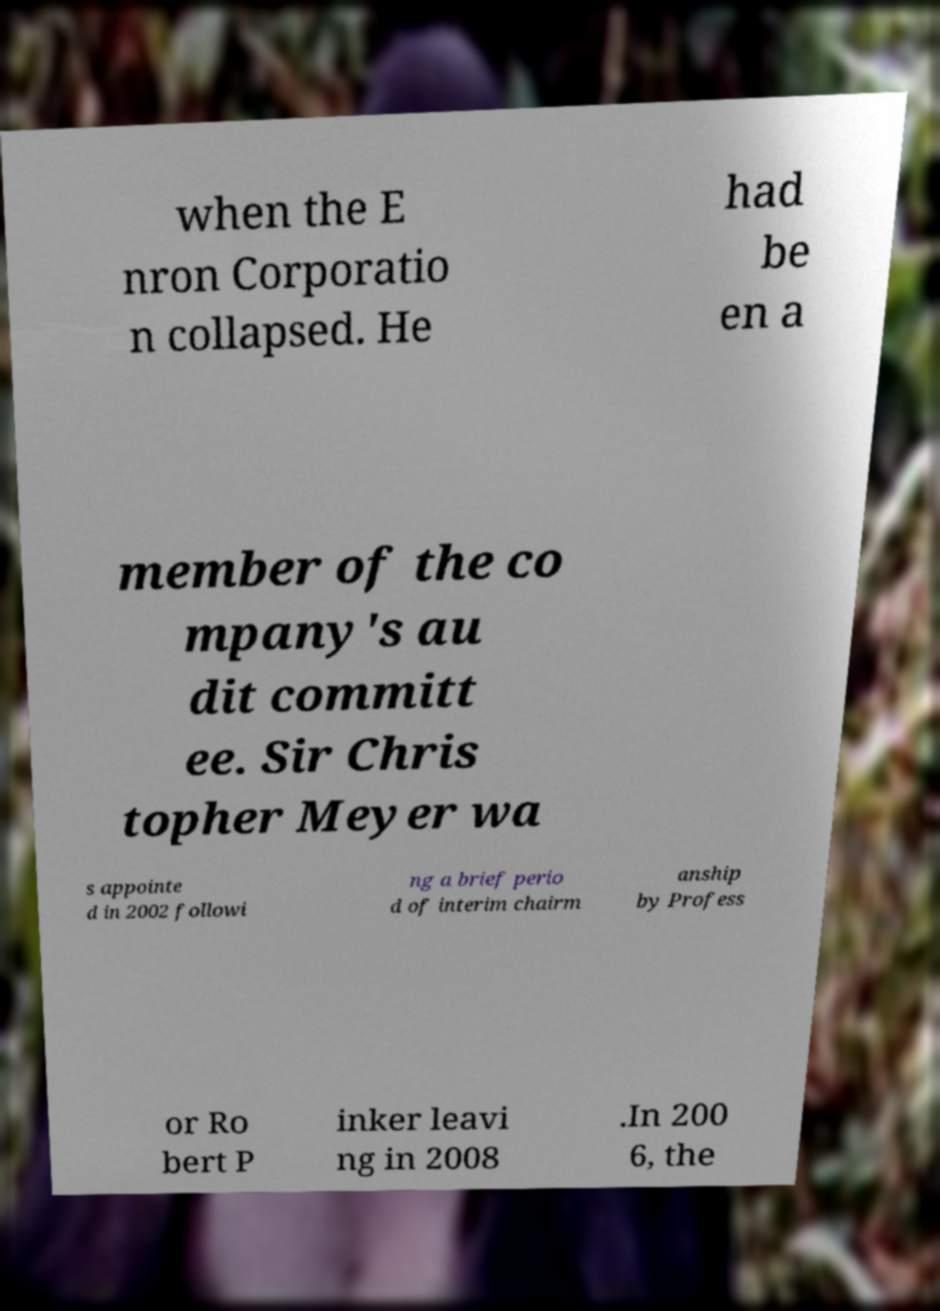Could you assist in decoding the text presented in this image and type it out clearly? when the E nron Corporatio n collapsed. He had be en a member of the co mpany's au dit committ ee. Sir Chris topher Meyer wa s appointe d in 2002 followi ng a brief perio d of interim chairm anship by Profess or Ro bert P inker leavi ng in 2008 .In 200 6, the 